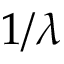Convert formula to latex. <formula><loc_0><loc_0><loc_500><loc_500>1 / \lambda</formula> 